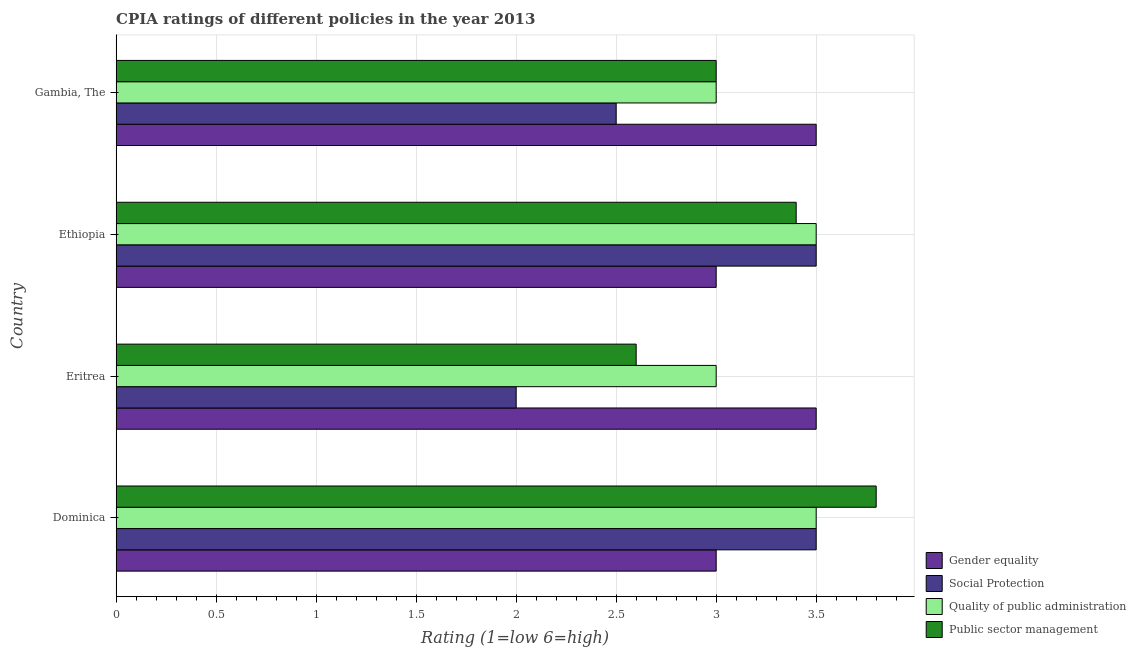How many bars are there on the 4th tick from the bottom?
Your answer should be very brief. 4. What is the label of the 1st group of bars from the top?
Make the answer very short. Gambia, The. What is the cpia rating of quality of public administration in Eritrea?
Ensure brevity in your answer.  3. Across all countries, what is the maximum cpia rating of gender equality?
Offer a very short reply. 3.5. In which country was the cpia rating of quality of public administration maximum?
Keep it short and to the point. Dominica. In which country was the cpia rating of social protection minimum?
Provide a short and direct response. Eritrea. What is the average cpia rating of public sector management per country?
Your answer should be very brief. 3.2. What is the ratio of the cpia rating of public sector management in Eritrea to that in Gambia, The?
Give a very brief answer. 0.87. Is the cpia rating of public sector management in Dominica less than that in Gambia, The?
Your answer should be very brief. No. What is the difference between the highest and the second highest cpia rating of social protection?
Your response must be concise. 0. What does the 1st bar from the top in Gambia, The represents?
Your answer should be compact. Public sector management. What does the 1st bar from the bottom in Ethiopia represents?
Give a very brief answer. Gender equality. How many bars are there?
Provide a short and direct response. 16. How many countries are there in the graph?
Your answer should be very brief. 4. What is the difference between two consecutive major ticks on the X-axis?
Provide a short and direct response. 0.5. Does the graph contain any zero values?
Keep it short and to the point. No. How many legend labels are there?
Keep it short and to the point. 4. What is the title of the graph?
Offer a terse response. CPIA ratings of different policies in the year 2013. What is the label or title of the Y-axis?
Make the answer very short. Country. What is the Rating (1=low 6=high) of Public sector management in Dominica?
Provide a succinct answer. 3.8. What is the Rating (1=low 6=high) of Quality of public administration in Eritrea?
Provide a short and direct response. 3. What is the Rating (1=low 6=high) in Public sector management in Eritrea?
Ensure brevity in your answer.  2.6. What is the Rating (1=low 6=high) of Gender equality in Ethiopia?
Give a very brief answer. 3. What is the Rating (1=low 6=high) in Social Protection in Ethiopia?
Provide a short and direct response. 3.5. What is the Rating (1=low 6=high) of Gender equality in Gambia, The?
Keep it short and to the point. 3.5. What is the Rating (1=low 6=high) of Social Protection in Gambia, The?
Give a very brief answer. 2.5. What is the Rating (1=low 6=high) of Quality of public administration in Gambia, The?
Provide a short and direct response. 3. Across all countries, what is the minimum Rating (1=low 6=high) in Gender equality?
Provide a succinct answer. 3. What is the total Rating (1=low 6=high) in Social Protection in the graph?
Your answer should be very brief. 11.5. What is the total Rating (1=low 6=high) of Quality of public administration in the graph?
Offer a very short reply. 13. What is the total Rating (1=low 6=high) of Public sector management in the graph?
Provide a short and direct response. 12.8. What is the difference between the Rating (1=low 6=high) of Social Protection in Dominica and that in Eritrea?
Offer a terse response. 1.5. What is the difference between the Rating (1=low 6=high) of Public sector management in Dominica and that in Eritrea?
Provide a short and direct response. 1.2. What is the difference between the Rating (1=low 6=high) in Quality of public administration in Dominica and that in Ethiopia?
Provide a short and direct response. 0. What is the difference between the Rating (1=low 6=high) of Public sector management in Dominica and that in Ethiopia?
Give a very brief answer. 0.4. What is the difference between the Rating (1=low 6=high) in Gender equality in Dominica and that in Gambia, The?
Offer a terse response. -0.5. What is the difference between the Rating (1=low 6=high) of Social Protection in Dominica and that in Gambia, The?
Provide a succinct answer. 1. What is the difference between the Rating (1=low 6=high) of Gender equality in Eritrea and that in Ethiopia?
Provide a succinct answer. 0.5. What is the difference between the Rating (1=low 6=high) of Social Protection in Eritrea and that in Ethiopia?
Make the answer very short. -1.5. What is the difference between the Rating (1=low 6=high) in Quality of public administration in Eritrea and that in Ethiopia?
Your answer should be very brief. -0.5. What is the difference between the Rating (1=low 6=high) in Public sector management in Eritrea and that in Ethiopia?
Provide a succinct answer. -0.8. What is the difference between the Rating (1=low 6=high) of Gender equality in Eritrea and that in Gambia, The?
Make the answer very short. 0. What is the difference between the Rating (1=low 6=high) in Quality of public administration in Eritrea and that in Gambia, The?
Provide a succinct answer. 0. What is the difference between the Rating (1=low 6=high) of Gender equality in Ethiopia and that in Gambia, The?
Your response must be concise. -0.5. What is the difference between the Rating (1=low 6=high) of Social Protection in Ethiopia and that in Gambia, The?
Offer a very short reply. 1. What is the difference between the Rating (1=low 6=high) of Quality of public administration in Ethiopia and that in Gambia, The?
Give a very brief answer. 0.5. What is the difference between the Rating (1=low 6=high) in Public sector management in Ethiopia and that in Gambia, The?
Your response must be concise. 0.4. What is the difference between the Rating (1=low 6=high) of Gender equality in Dominica and the Rating (1=low 6=high) of Public sector management in Eritrea?
Your answer should be very brief. 0.4. What is the difference between the Rating (1=low 6=high) in Social Protection in Dominica and the Rating (1=low 6=high) in Quality of public administration in Eritrea?
Provide a short and direct response. 0.5. What is the difference between the Rating (1=low 6=high) in Social Protection in Dominica and the Rating (1=low 6=high) in Public sector management in Eritrea?
Offer a very short reply. 0.9. What is the difference between the Rating (1=low 6=high) of Quality of public administration in Dominica and the Rating (1=low 6=high) of Public sector management in Eritrea?
Offer a very short reply. 0.9. What is the difference between the Rating (1=low 6=high) of Gender equality in Dominica and the Rating (1=low 6=high) of Social Protection in Ethiopia?
Keep it short and to the point. -0.5. What is the difference between the Rating (1=low 6=high) of Gender equality in Dominica and the Rating (1=low 6=high) of Public sector management in Ethiopia?
Give a very brief answer. -0.4. What is the difference between the Rating (1=low 6=high) of Social Protection in Dominica and the Rating (1=low 6=high) of Public sector management in Ethiopia?
Your answer should be compact. 0.1. What is the difference between the Rating (1=low 6=high) of Gender equality in Dominica and the Rating (1=low 6=high) of Social Protection in Gambia, The?
Your answer should be compact. 0.5. What is the difference between the Rating (1=low 6=high) in Gender equality in Dominica and the Rating (1=low 6=high) in Quality of public administration in Gambia, The?
Provide a succinct answer. 0. What is the difference between the Rating (1=low 6=high) in Social Protection in Dominica and the Rating (1=low 6=high) in Quality of public administration in Gambia, The?
Your answer should be compact. 0.5. What is the difference between the Rating (1=low 6=high) in Quality of public administration in Dominica and the Rating (1=low 6=high) in Public sector management in Gambia, The?
Keep it short and to the point. 0.5. What is the difference between the Rating (1=low 6=high) of Gender equality in Eritrea and the Rating (1=low 6=high) of Public sector management in Ethiopia?
Give a very brief answer. 0.1. What is the difference between the Rating (1=low 6=high) in Social Protection in Eritrea and the Rating (1=low 6=high) in Public sector management in Ethiopia?
Offer a terse response. -1.4. What is the difference between the Rating (1=low 6=high) of Quality of public administration in Eritrea and the Rating (1=low 6=high) of Public sector management in Ethiopia?
Provide a short and direct response. -0.4. What is the difference between the Rating (1=low 6=high) of Gender equality in Eritrea and the Rating (1=low 6=high) of Social Protection in Gambia, The?
Offer a very short reply. 1. What is the difference between the Rating (1=low 6=high) of Gender equality in Eritrea and the Rating (1=low 6=high) of Quality of public administration in Gambia, The?
Provide a succinct answer. 0.5. What is the difference between the Rating (1=low 6=high) of Quality of public administration in Eritrea and the Rating (1=low 6=high) of Public sector management in Gambia, The?
Make the answer very short. 0. What is the difference between the Rating (1=low 6=high) of Gender equality in Ethiopia and the Rating (1=low 6=high) of Quality of public administration in Gambia, The?
Your answer should be very brief. 0. What is the difference between the Rating (1=low 6=high) in Gender equality in Ethiopia and the Rating (1=low 6=high) in Public sector management in Gambia, The?
Offer a very short reply. 0. What is the difference between the Rating (1=low 6=high) of Social Protection in Ethiopia and the Rating (1=low 6=high) of Quality of public administration in Gambia, The?
Provide a short and direct response. 0.5. What is the difference between the Rating (1=low 6=high) in Social Protection in Ethiopia and the Rating (1=low 6=high) in Public sector management in Gambia, The?
Offer a very short reply. 0.5. What is the difference between the Rating (1=low 6=high) of Quality of public administration in Ethiopia and the Rating (1=low 6=high) of Public sector management in Gambia, The?
Provide a short and direct response. 0.5. What is the average Rating (1=low 6=high) of Gender equality per country?
Offer a terse response. 3.25. What is the average Rating (1=low 6=high) in Social Protection per country?
Provide a succinct answer. 2.88. What is the average Rating (1=low 6=high) of Quality of public administration per country?
Your response must be concise. 3.25. What is the difference between the Rating (1=low 6=high) of Gender equality and Rating (1=low 6=high) of Quality of public administration in Dominica?
Make the answer very short. -0.5. What is the difference between the Rating (1=low 6=high) in Gender equality and Rating (1=low 6=high) in Public sector management in Dominica?
Give a very brief answer. -0.8. What is the difference between the Rating (1=low 6=high) in Social Protection and Rating (1=low 6=high) in Quality of public administration in Dominica?
Provide a short and direct response. 0. What is the difference between the Rating (1=low 6=high) in Social Protection and Rating (1=low 6=high) in Public sector management in Dominica?
Give a very brief answer. -0.3. What is the difference between the Rating (1=low 6=high) in Quality of public administration and Rating (1=low 6=high) in Public sector management in Dominica?
Provide a short and direct response. -0.3. What is the difference between the Rating (1=low 6=high) of Gender equality and Rating (1=low 6=high) of Social Protection in Eritrea?
Make the answer very short. 1.5. What is the difference between the Rating (1=low 6=high) of Gender equality and Rating (1=low 6=high) of Quality of public administration in Eritrea?
Provide a short and direct response. 0.5. What is the difference between the Rating (1=low 6=high) of Quality of public administration and Rating (1=low 6=high) of Public sector management in Eritrea?
Make the answer very short. 0.4. What is the difference between the Rating (1=low 6=high) in Gender equality and Rating (1=low 6=high) in Public sector management in Ethiopia?
Offer a terse response. -0.4. What is the difference between the Rating (1=low 6=high) in Social Protection and Rating (1=low 6=high) in Quality of public administration in Ethiopia?
Keep it short and to the point. 0. What is the difference between the Rating (1=low 6=high) in Gender equality and Rating (1=low 6=high) in Public sector management in Gambia, The?
Your answer should be compact. 0.5. What is the difference between the Rating (1=low 6=high) of Social Protection and Rating (1=low 6=high) of Public sector management in Gambia, The?
Your answer should be compact. -0.5. What is the difference between the Rating (1=low 6=high) in Quality of public administration and Rating (1=low 6=high) in Public sector management in Gambia, The?
Your response must be concise. 0. What is the ratio of the Rating (1=low 6=high) in Social Protection in Dominica to that in Eritrea?
Your answer should be very brief. 1.75. What is the ratio of the Rating (1=low 6=high) of Public sector management in Dominica to that in Eritrea?
Keep it short and to the point. 1.46. What is the ratio of the Rating (1=low 6=high) in Gender equality in Dominica to that in Ethiopia?
Ensure brevity in your answer.  1. What is the ratio of the Rating (1=low 6=high) in Social Protection in Dominica to that in Ethiopia?
Give a very brief answer. 1. What is the ratio of the Rating (1=low 6=high) in Quality of public administration in Dominica to that in Ethiopia?
Offer a very short reply. 1. What is the ratio of the Rating (1=low 6=high) in Public sector management in Dominica to that in Ethiopia?
Your response must be concise. 1.12. What is the ratio of the Rating (1=low 6=high) in Gender equality in Dominica to that in Gambia, The?
Your response must be concise. 0.86. What is the ratio of the Rating (1=low 6=high) of Public sector management in Dominica to that in Gambia, The?
Your answer should be very brief. 1.27. What is the ratio of the Rating (1=low 6=high) in Gender equality in Eritrea to that in Ethiopia?
Your answer should be very brief. 1.17. What is the ratio of the Rating (1=low 6=high) in Social Protection in Eritrea to that in Ethiopia?
Your response must be concise. 0.57. What is the ratio of the Rating (1=low 6=high) in Quality of public administration in Eritrea to that in Ethiopia?
Make the answer very short. 0.86. What is the ratio of the Rating (1=low 6=high) in Public sector management in Eritrea to that in Ethiopia?
Ensure brevity in your answer.  0.76. What is the ratio of the Rating (1=low 6=high) of Gender equality in Eritrea to that in Gambia, The?
Provide a succinct answer. 1. What is the ratio of the Rating (1=low 6=high) of Quality of public administration in Eritrea to that in Gambia, The?
Offer a terse response. 1. What is the ratio of the Rating (1=low 6=high) of Public sector management in Eritrea to that in Gambia, The?
Give a very brief answer. 0.87. What is the ratio of the Rating (1=low 6=high) of Social Protection in Ethiopia to that in Gambia, The?
Your response must be concise. 1.4. What is the ratio of the Rating (1=low 6=high) in Public sector management in Ethiopia to that in Gambia, The?
Offer a terse response. 1.13. What is the difference between the highest and the second highest Rating (1=low 6=high) in Gender equality?
Provide a short and direct response. 0. What is the difference between the highest and the second highest Rating (1=low 6=high) in Social Protection?
Offer a terse response. 0. What is the difference between the highest and the second highest Rating (1=low 6=high) of Public sector management?
Give a very brief answer. 0.4. What is the difference between the highest and the lowest Rating (1=low 6=high) of Gender equality?
Ensure brevity in your answer.  0.5. What is the difference between the highest and the lowest Rating (1=low 6=high) in Social Protection?
Offer a terse response. 1.5. What is the difference between the highest and the lowest Rating (1=low 6=high) of Quality of public administration?
Your answer should be very brief. 0.5. 